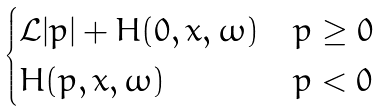Convert formula to latex. <formula><loc_0><loc_0><loc_500><loc_500>\begin{cases} \mathcal { L } | p | + H ( 0 , x , \omega ) & p \geq 0 \\ H ( p , x , \omega ) & p < 0 \end{cases}</formula> 